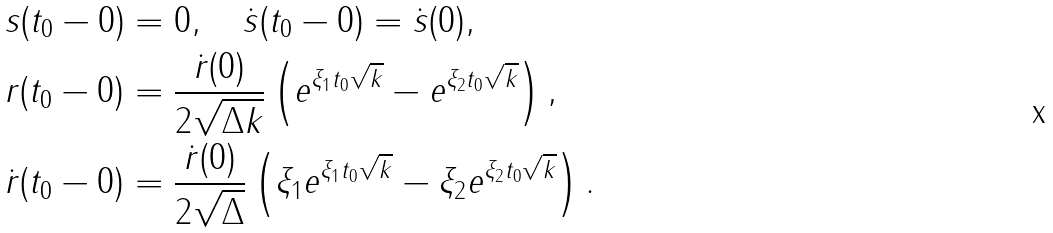<formula> <loc_0><loc_0><loc_500><loc_500>& s ( t _ { 0 } - 0 ) = 0 , \quad \dot { s } ( t _ { 0 } - 0 ) = \dot { s } ( 0 ) , \\ & r ( t _ { 0 } - 0 ) = \frac { \dot { r } ( 0 ) } { 2 \sqrt { \Delta k } } \left ( e ^ { \xi _ { 1 } t _ { 0 } \sqrt { k } } - e ^ { \xi _ { 2 } t _ { 0 } \sqrt { k } } \right ) , \\ & \dot { r } ( t _ { 0 } - 0 ) = \frac { \dot { r } ( 0 ) } { 2 \sqrt { \Delta } } \left ( \xi _ { 1 } e ^ { \xi _ { 1 } t _ { 0 } \sqrt { k } } - \xi _ { 2 } e ^ { \xi _ { 2 } t _ { 0 } \sqrt { k } } \right ) .</formula> 